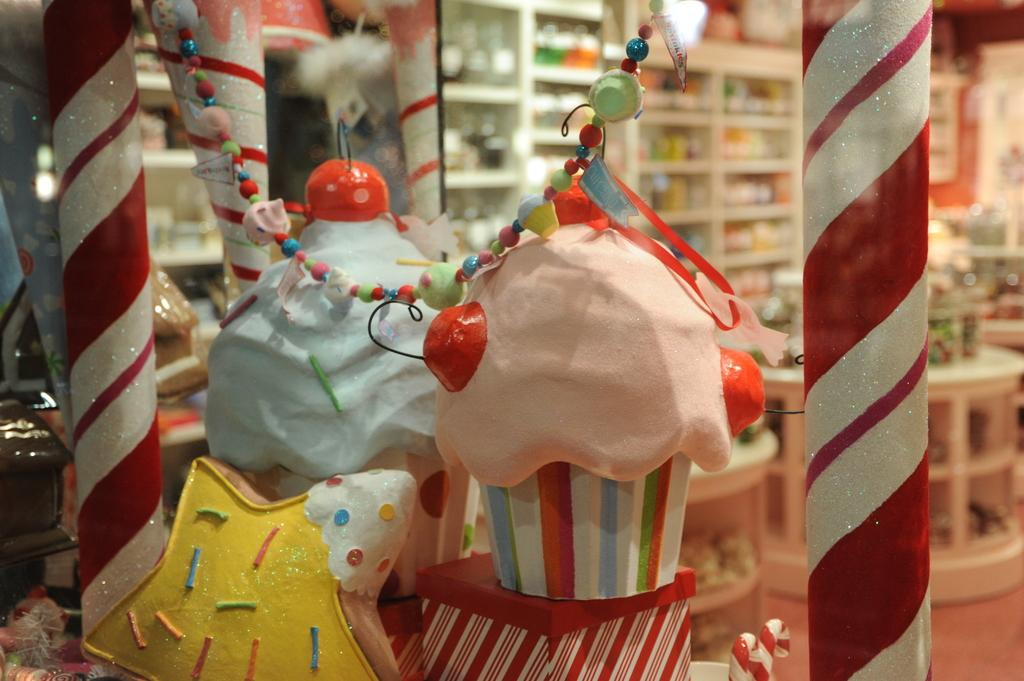What type of establishment is depicted in the image? The location is a store. What can be found in the store? There are numerous objects available in the store. Is there any specific color or item related to the flooring in the store? Yes, there is a red color mat in the store. What activity is the stranger participating in with the hydrant in the image? There is no stranger or hydrant present in the image. 